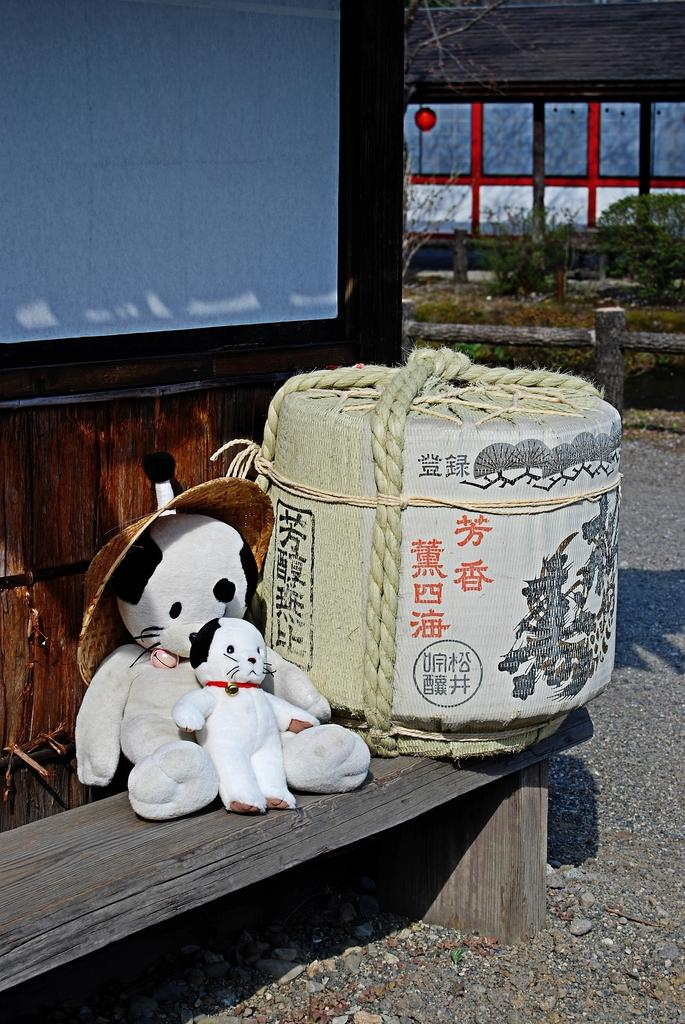What type of toys can be seen in the image? There are soft toys in the image. Where are the soft toys located? The soft toys are on a wooden bench in the image. What can be seen in the background of the image? There are plants and other unspecified things in the background of the image. What type of honey can be seen dripping from the soft toys in the image? There is no honey present in the image; it features soft toys on a wooden bench with plants and other unspecified things in the background. 